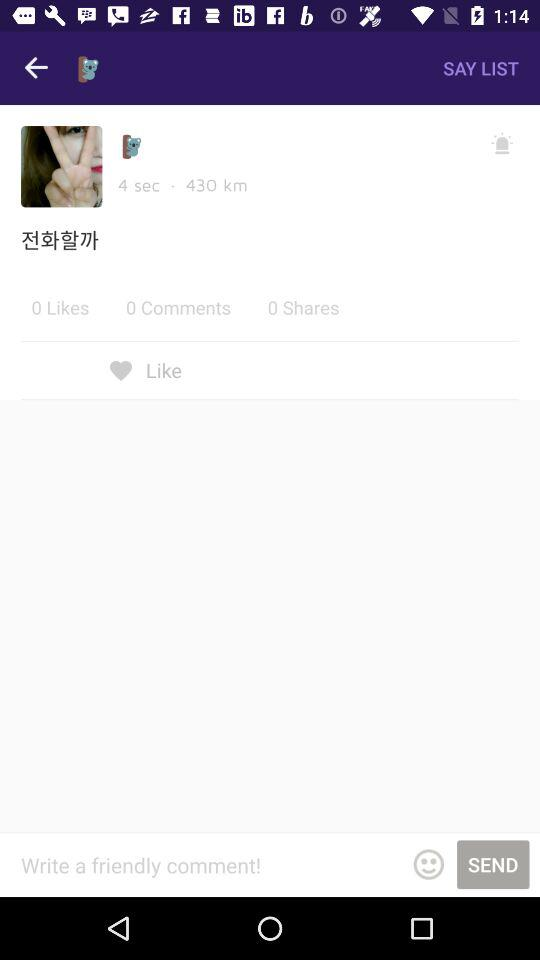What is the time mentioned? The mentioned time is 4 seconds. 